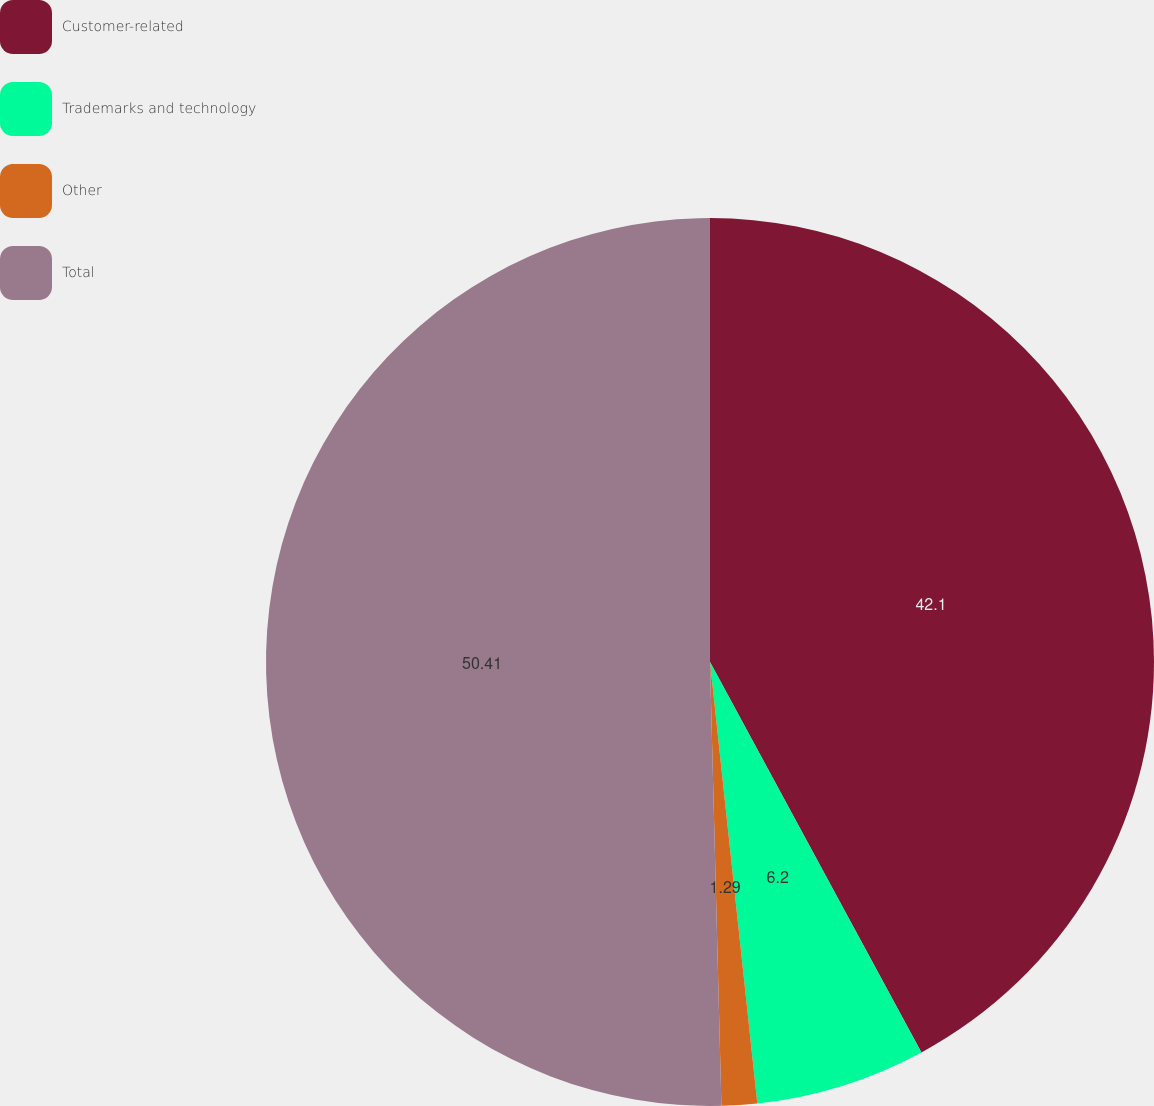Convert chart. <chart><loc_0><loc_0><loc_500><loc_500><pie_chart><fcel>Customer-related<fcel>Trademarks and technology<fcel>Other<fcel>Total<nl><fcel>42.1%<fcel>6.2%<fcel>1.29%<fcel>50.41%<nl></chart> 